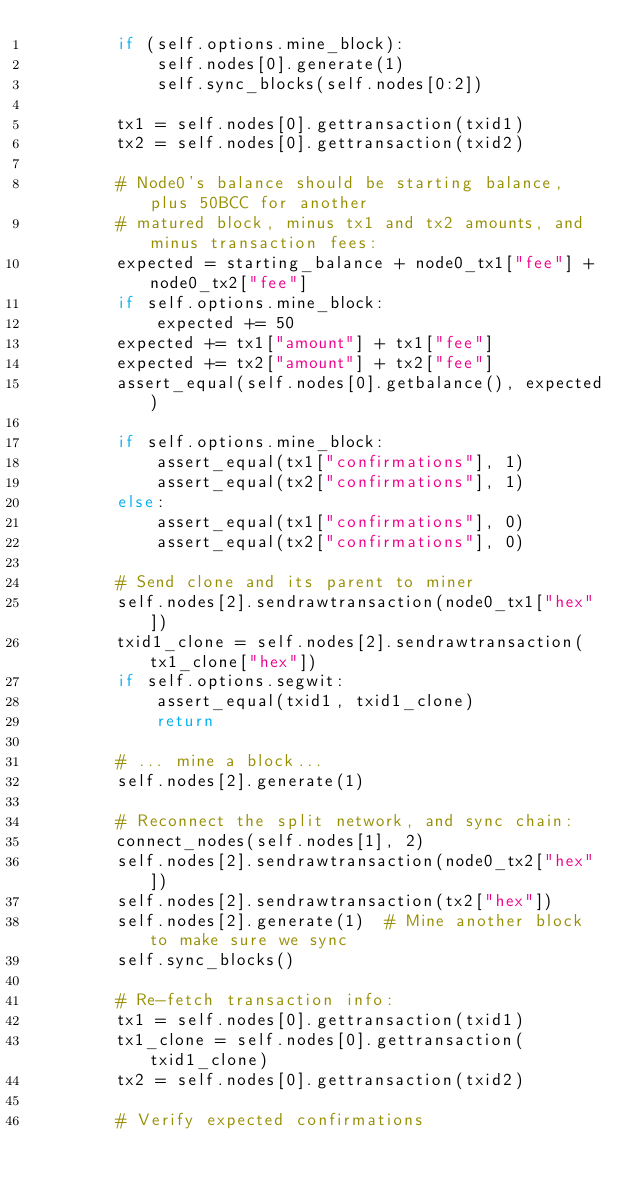<code> <loc_0><loc_0><loc_500><loc_500><_Python_>        if (self.options.mine_block):
            self.nodes[0].generate(1)
            self.sync_blocks(self.nodes[0:2])

        tx1 = self.nodes[0].gettransaction(txid1)
        tx2 = self.nodes[0].gettransaction(txid2)

        # Node0's balance should be starting balance, plus 50BCC for another
        # matured block, minus tx1 and tx2 amounts, and minus transaction fees:
        expected = starting_balance + node0_tx1["fee"] + node0_tx2["fee"]
        if self.options.mine_block:
            expected += 50
        expected += tx1["amount"] + tx1["fee"]
        expected += tx2["amount"] + tx2["fee"]
        assert_equal(self.nodes[0].getbalance(), expected)

        if self.options.mine_block:
            assert_equal(tx1["confirmations"], 1)
            assert_equal(tx2["confirmations"], 1)
        else:
            assert_equal(tx1["confirmations"], 0)
            assert_equal(tx2["confirmations"], 0)

        # Send clone and its parent to miner
        self.nodes[2].sendrawtransaction(node0_tx1["hex"])
        txid1_clone = self.nodes[2].sendrawtransaction(tx1_clone["hex"])
        if self.options.segwit:
            assert_equal(txid1, txid1_clone)
            return

        # ... mine a block...
        self.nodes[2].generate(1)

        # Reconnect the split network, and sync chain:
        connect_nodes(self.nodes[1], 2)
        self.nodes[2].sendrawtransaction(node0_tx2["hex"])
        self.nodes[2].sendrawtransaction(tx2["hex"])
        self.nodes[2].generate(1)  # Mine another block to make sure we sync
        self.sync_blocks()

        # Re-fetch transaction info:
        tx1 = self.nodes[0].gettransaction(txid1)
        tx1_clone = self.nodes[0].gettransaction(txid1_clone)
        tx2 = self.nodes[0].gettransaction(txid2)

        # Verify expected confirmations</code> 